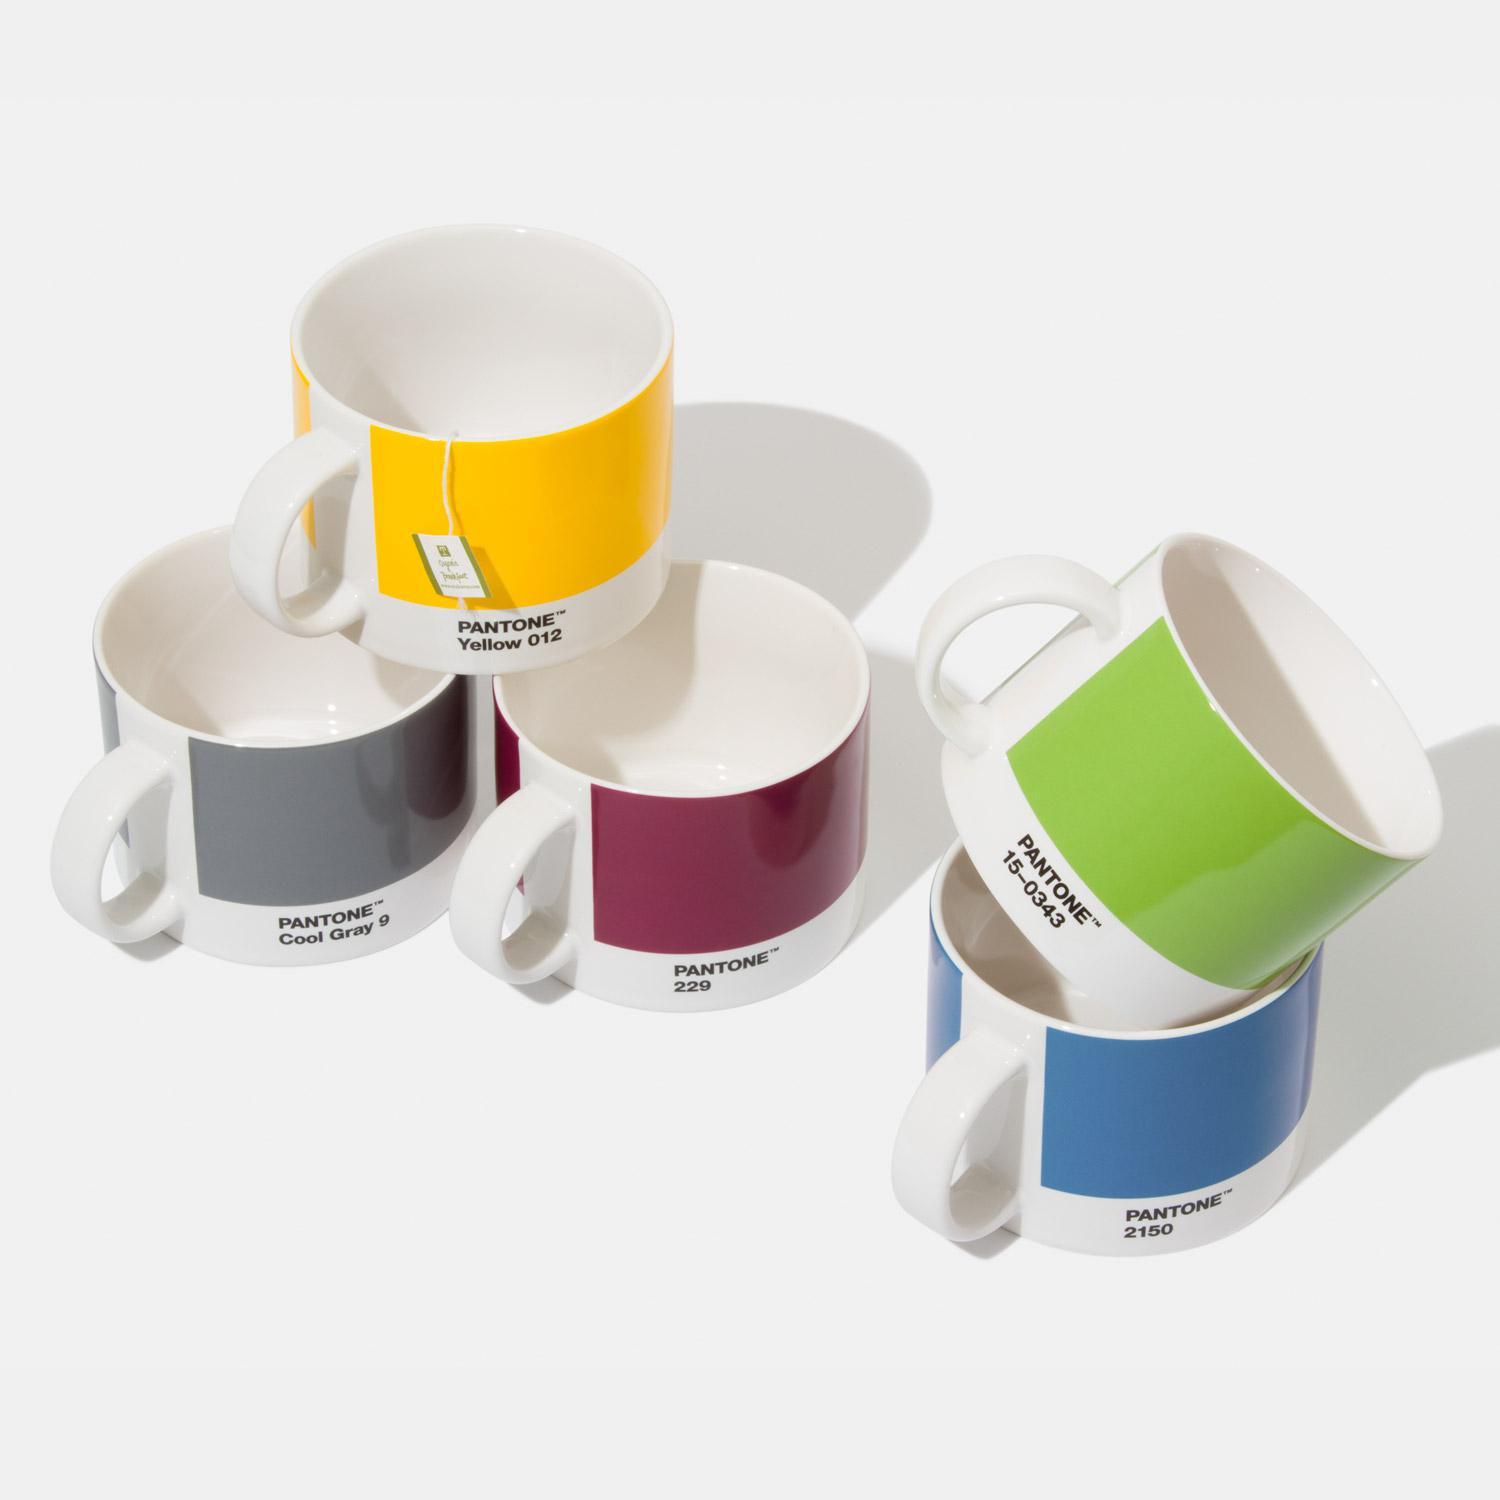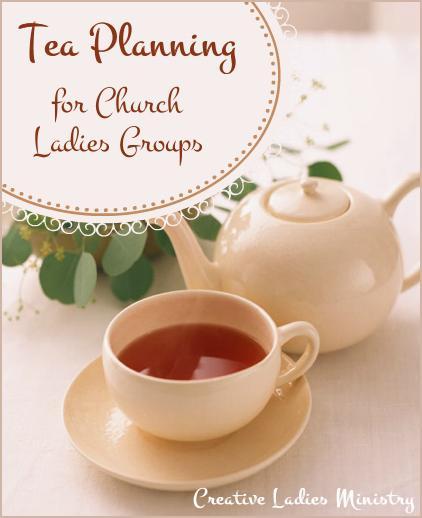The first image is the image on the left, the second image is the image on the right. For the images displayed, is the sentence "In at least one image there are five coffee cups and in the there there is a tea kettle." factually correct? Answer yes or no. Yes. 